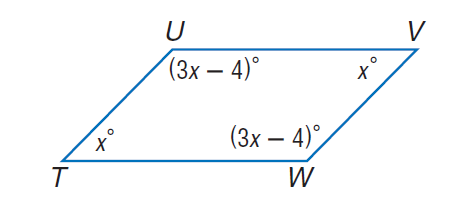Answer the mathemtical geometry problem and directly provide the correct option letter.
Question: Find m \angle U.
Choices: A: 44 B: 46 C: 54 D: 134 D 